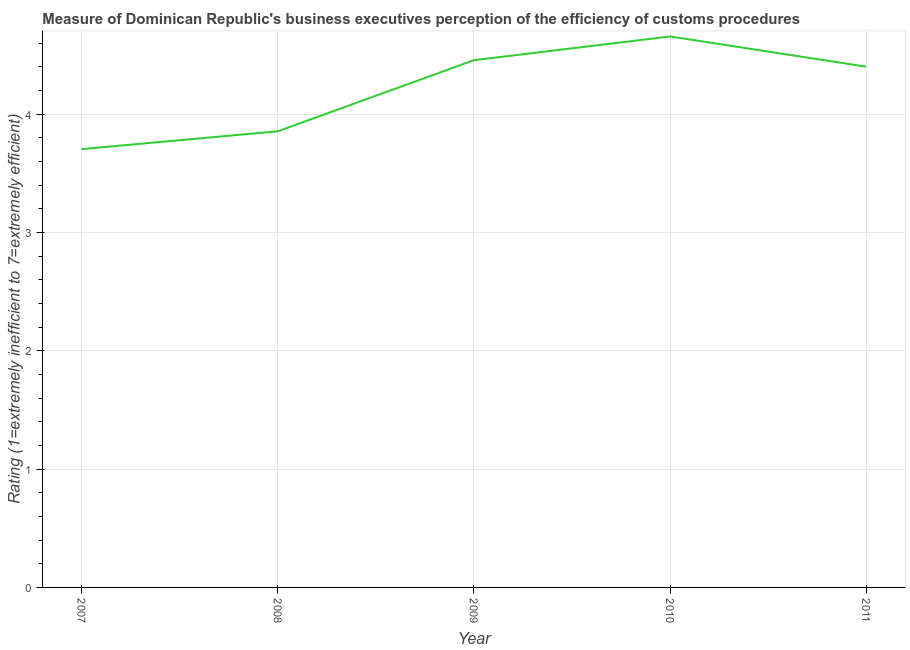What is the rating measuring burden of customs procedure in 2010?
Ensure brevity in your answer.  4.66. Across all years, what is the maximum rating measuring burden of customs procedure?
Provide a succinct answer. 4.66. Across all years, what is the minimum rating measuring burden of customs procedure?
Give a very brief answer. 3.7. In which year was the rating measuring burden of customs procedure maximum?
Provide a short and direct response. 2010. What is the sum of the rating measuring burden of customs procedure?
Provide a short and direct response. 21.07. What is the difference between the rating measuring burden of customs procedure in 2007 and 2010?
Your response must be concise. -0.95. What is the average rating measuring burden of customs procedure per year?
Offer a very short reply. 4.21. In how many years, is the rating measuring burden of customs procedure greater than 0.6000000000000001 ?
Offer a terse response. 5. Do a majority of the years between 2009 and 2007 (inclusive) have rating measuring burden of customs procedure greater than 2 ?
Your response must be concise. No. What is the ratio of the rating measuring burden of customs procedure in 2010 to that in 2011?
Keep it short and to the point. 1.06. Is the difference between the rating measuring burden of customs procedure in 2007 and 2011 greater than the difference between any two years?
Your answer should be very brief. No. What is the difference between the highest and the second highest rating measuring burden of customs procedure?
Keep it short and to the point. 0.2. Is the sum of the rating measuring burden of customs procedure in 2007 and 2010 greater than the maximum rating measuring burden of customs procedure across all years?
Offer a terse response. Yes. What is the difference between the highest and the lowest rating measuring burden of customs procedure?
Ensure brevity in your answer.  0.95. In how many years, is the rating measuring burden of customs procedure greater than the average rating measuring burden of customs procedure taken over all years?
Provide a succinct answer. 3. How many lines are there?
Ensure brevity in your answer.  1. How many years are there in the graph?
Your response must be concise. 5. Are the values on the major ticks of Y-axis written in scientific E-notation?
Keep it short and to the point. No. Does the graph contain grids?
Give a very brief answer. Yes. What is the title of the graph?
Your answer should be very brief. Measure of Dominican Republic's business executives perception of the efficiency of customs procedures. What is the label or title of the Y-axis?
Your answer should be compact. Rating (1=extremely inefficient to 7=extremely efficient). What is the Rating (1=extremely inefficient to 7=extremely efficient) in 2007?
Keep it short and to the point. 3.7. What is the Rating (1=extremely inefficient to 7=extremely efficient) in 2008?
Ensure brevity in your answer.  3.85. What is the Rating (1=extremely inefficient to 7=extremely efficient) of 2009?
Provide a short and direct response. 4.46. What is the Rating (1=extremely inefficient to 7=extremely efficient) of 2010?
Provide a succinct answer. 4.66. What is the Rating (1=extremely inefficient to 7=extremely efficient) in 2011?
Make the answer very short. 4.4. What is the difference between the Rating (1=extremely inefficient to 7=extremely efficient) in 2007 and 2008?
Give a very brief answer. -0.15. What is the difference between the Rating (1=extremely inefficient to 7=extremely efficient) in 2007 and 2009?
Offer a terse response. -0.75. What is the difference between the Rating (1=extremely inefficient to 7=extremely efficient) in 2007 and 2010?
Your answer should be compact. -0.95. What is the difference between the Rating (1=extremely inefficient to 7=extremely efficient) in 2007 and 2011?
Ensure brevity in your answer.  -0.7. What is the difference between the Rating (1=extremely inefficient to 7=extremely efficient) in 2008 and 2009?
Provide a succinct answer. -0.6. What is the difference between the Rating (1=extremely inefficient to 7=extremely efficient) in 2008 and 2010?
Provide a succinct answer. -0.8. What is the difference between the Rating (1=extremely inefficient to 7=extremely efficient) in 2008 and 2011?
Make the answer very short. -0.55. What is the difference between the Rating (1=extremely inefficient to 7=extremely efficient) in 2009 and 2010?
Give a very brief answer. -0.2. What is the difference between the Rating (1=extremely inefficient to 7=extremely efficient) in 2009 and 2011?
Provide a succinct answer. 0.06. What is the difference between the Rating (1=extremely inefficient to 7=extremely efficient) in 2010 and 2011?
Offer a terse response. 0.26. What is the ratio of the Rating (1=extremely inefficient to 7=extremely efficient) in 2007 to that in 2008?
Your answer should be compact. 0.96. What is the ratio of the Rating (1=extremely inefficient to 7=extremely efficient) in 2007 to that in 2009?
Offer a very short reply. 0.83. What is the ratio of the Rating (1=extremely inefficient to 7=extremely efficient) in 2007 to that in 2010?
Provide a succinct answer. 0.8. What is the ratio of the Rating (1=extremely inefficient to 7=extremely efficient) in 2007 to that in 2011?
Offer a very short reply. 0.84. What is the ratio of the Rating (1=extremely inefficient to 7=extremely efficient) in 2008 to that in 2009?
Make the answer very short. 0.86. What is the ratio of the Rating (1=extremely inefficient to 7=extremely efficient) in 2008 to that in 2010?
Provide a short and direct response. 0.83. What is the ratio of the Rating (1=extremely inefficient to 7=extremely efficient) in 2008 to that in 2011?
Keep it short and to the point. 0.88. What is the ratio of the Rating (1=extremely inefficient to 7=extremely efficient) in 2009 to that in 2011?
Provide a short and direct response. 1.01. What is the ratio of the Rating (1=extremely inefficient to 7=extremely efficient) in 2010 to that in 2011?
Give a very brief answer. 1.06. 